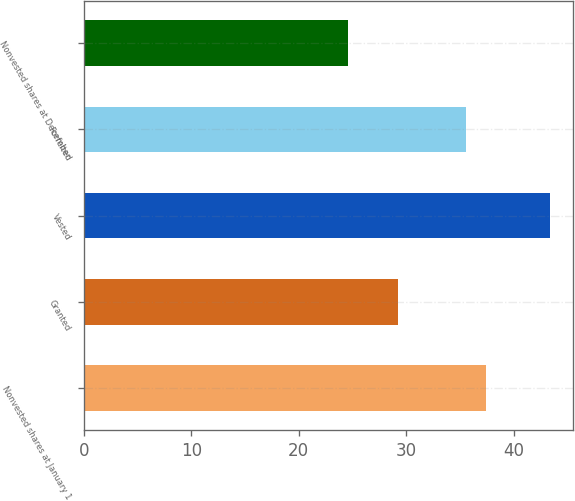Convert chart. <chart><loc_0><loc_0><loc_500><loc_500><bar_chart><fcel>Nonvested shares at January 1<fcel>Granted<fcel>Vested<fcel>Forfeited<fcel>Nonvested shares at December<nl><fcel>37.46<fcel>29.24<fcel>43.39<fcel>35.58<fcel>24.58<nl></chart> 